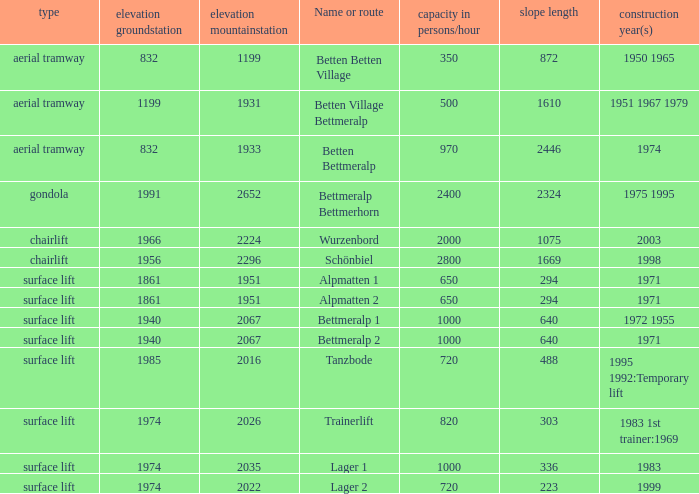Which slope length has a type of surface lift, and an elevation groundstation smaller than 1974, and a construction year(s) of 1971, and a Name or route of alpmatten 1? 294.0. 